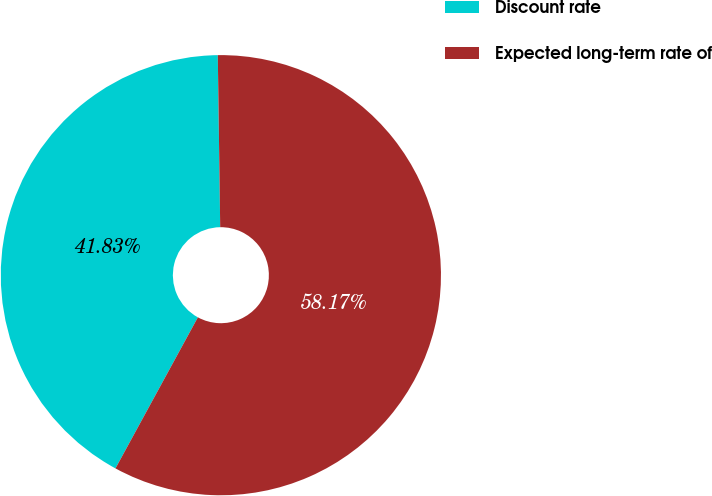<chart> <loc_0><loc_0><loc_500><loc_500><pie_chart><fcel>Discount rate<fcel>Expected long-term rate of<nl><fcel>41.83%<fcel>58.17%<nl></chart> 